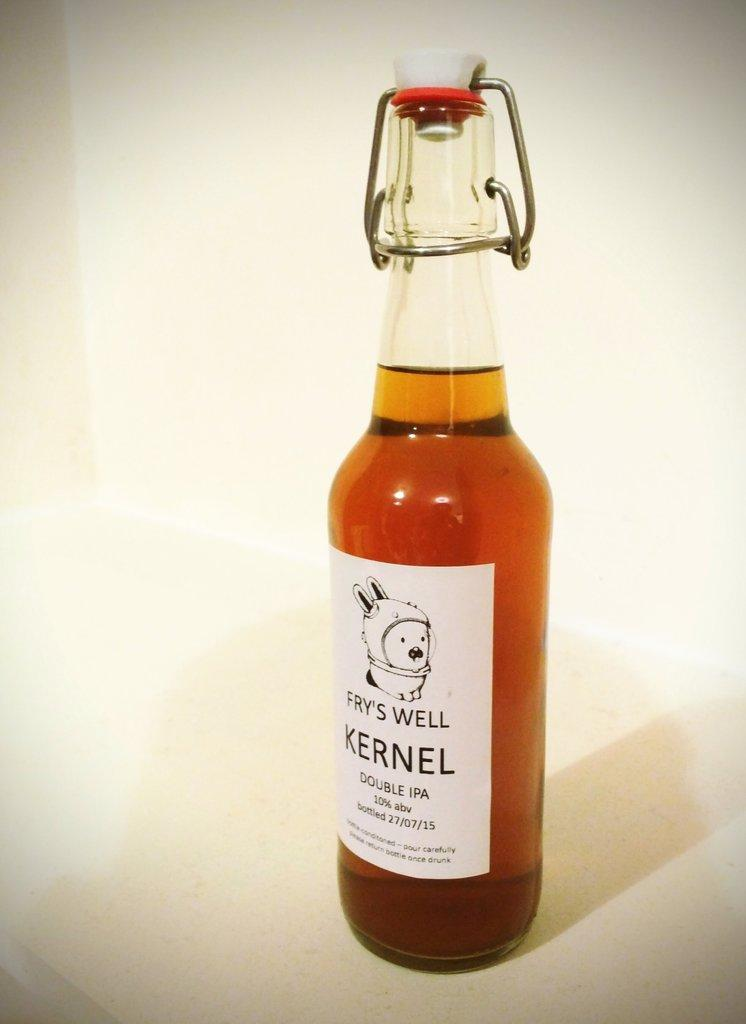<image>
Give a short and clear explanation of the subsequent image. A bottle is marked Fry's Well and is full. 